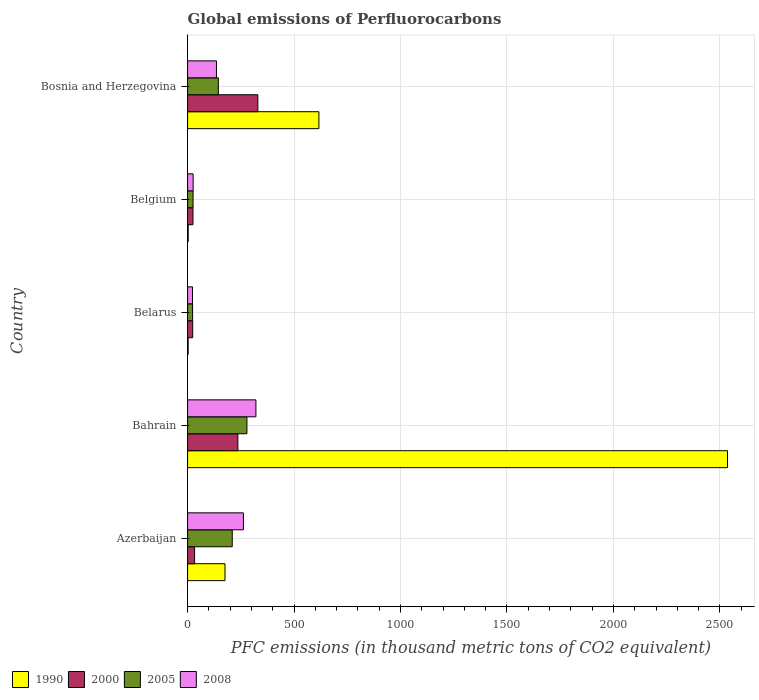How many different coloured bars are there?
Your answer should be compact. 4. Are the number of bars on each tick of the Y-axis equal?
Keep it short and to the point. Yes. How many bars are there on the 3rd tick from the bottom?
Offer a very short reply. 4. What is the label of the 5th group of bars from the top?
Provide a short and direct response. Azerbaijan. What is the global emissions of Perfluorocarbons in 2005 in Belgium?
Provide a succinct answer. 25.7. Across all countries, what is the maximum global emissions of Perfluorocarbons in 2008?
Offer a very short reply. 320.9. Across all countries, what is the minimum global emissions of Perfluorocarbons in 2005?
Your answer should be compact. 23.4. In which country was the global emissions of Perfluorocarbons in 2000 maximum?
Provide a short and direct response. Bosnia and Herzegovina. In which country was the global emissions of Perfluorocarbons in 1990 minimum?
Offer a terse response. Belarus. What is the total global emissions of Perfluorocarbons in 1990 in the graph?
Provide a short and direct response. 3333.5. What is the difference between the global emissions of Perfluorocarbons in 2005 in Azerbaijan and that in Belgium?
Your answer should be very brief. 184. What is the difference between the global emissions of Perfluorocarbons in 2005 in Belarus and the global emissions of Perfluorocarbons in 2000 in Belgium?
Provide a succinct answer. -1.8. What is the average global emissions of Perfluorocarbons in 2000 per country?
Your answer should be compact. 129.58. What is the difference between the global emissions of Perfluorocarbons in 1990 and global emissions of Perfluorocarbons in 2005 in Bosnia and Herzegovina?
Keep it short and to the point. 472.3. In how many countries, is the global emissions of Perfluorocarbons in 2000 greater than 1000 thousand metric tons?
Keep it short and to the point. 0. What is the ratio of the global emissions of Perfluorocarbons in 2005 in Azerbaijan to that in Belgium?
Offer a terse response. 8.16. Is the global emissions of Perfluorocarbons in 1990 in Azerbaijan less than that in Bahrain?
Provide a short and direct response. Yes. What is the difference between the highest and the second highest global emissions of Perfluorocarbons in 2000?
Offer a terse response. 93.8. What is the difference between the highest and the lowest global emissions of Perfluorocarbons in 2005?
Keep it short and to the point. 255.2. Is it the case that in every country, the sum of the global emissions of Perfluorocarbons in 2000 and global emissions of Perfluorocarbons in 2008 is greater than the sum of global emissions of Perfluorocarbons in 2005 and global emissions of Perfluorocarbons in 1990?
Your answer should be very brief. No. What does the 4th bar from the top in Bosnia and Herzegovina represents?
Your response must be concise. 1990. Is it the case that in every country, the sum of the global emissions of Perfluorocarbons in 2000 and global emissions of Perfluorocarbons in 2008 is greater than the global emissions of Perfluorocarbons in 1990?
Keep it short and to the point. No. How many bars are there?
Keep it short and to the point. 20. Does the graph contain grids?
Offer a very short reply. Yes. Where does the legend appear in the graph?
Ensure brevity in your answer.  Bottom left. How many legend labels are there?
Offer a terse response. 4. What is the title of the graph?
Offer a terse response. Global emissions of Perfluorocarbons. What is the label or title of the X-axis?
Provide a short and direct response. PFC emissions (in thousand metric tons of CO2 equivalent). What is the PFC emissions (in thousand metric tons of CO2 equivalent) of 1990 in Azerbaijan?
Your answer should be very brief. 175.6. What is the PFC emissions (in thousand metric tons of CO2 equivalent) in 2000 in Azerbaijan?
Provide a succinct answer. 32.8. What is the PFC emissions (in thousand metric tons of CO2 equivalent) in 2005 in Azerbaijan?
Make the answer very short. 209.7. What is the PFC emissions (in thousand metric tons of CO2 equivalent) of 2008 in Azerbaijan?
Your answer should be very brief. 262.2. What is the PFC emissions (in thousand metric tons of CO2 equivalent) of 1990 in Bahrain?
Make the answer very short. 2535.7. What is the PFC emissions (in thousand metric tons of CO2 equivalent) of 2000 in Bahrain?
Provide a short and direct response. 236.1. What is the PFC emissions (in thousand metric tons of CO2 equivalent) in 2005 in Bahrain?
Your answer should be compact. 278.6. What is the PFC emissions (in thousand metric tons of CO2 equivalent) in 2008 in Bahrain?
Your answer should be compact. 320.9. What is the PFC emissions (in thousand metric tons of CO2 equivalent) in 2000 in Belarus?
Provide a succinct answer. 23.9. What is the PFC emissions (in thousand metric tons of CO2 equivalent) in 2005 in Belarus?
Offer a terse response. 23.4. What is the PFC emissions (in thousand metric tons of CO2 equivalent) of 2008 in Belarus?
Your response must be concise. 23.1. What is the PFC emissions (in thousand metric tons of CO2 equivalent) in 2000 in Belgium?
Make the answer very short. 25.2. What is the PFC emissions (in thousand metric tons of CO2 equivalent) of 2005 in Belgium?
Provide a succinct answer. 25.7. What is the PFC emissions (in thousand metric tons of CO2 equivalent) of 2008 in Belgium?
Make the answer very short. 26. What is the PFC emissions (in thousand metric tons of CO2 equivalent) of 1990 in Bosnia and Herzegovina?
Your answer should be compact. 616.7. What is the PFC emissions (in thousand metric tons of CO2 equivalent) in 2000 in Bosnia and Herzegovina?
Offer a very short reply. 329.9. What is the PFC emissions (in thousand metric tons of CO2 equivalent) in 2005 in Bosnia and Herzegovina?
Ensure brevity in your answer.  144.4. What is the PFC emissions (in thousand metric tons of CO2 equivalent) of 2008 in Bosnia and Herzegovina?
Your response must be concise. 135.6. Across all countries, what is the maximum PFC emissions (in thousand metric tons of CO2 equivalent) in 1990?
Give a very brief answer. 2535.7. Across all countries, what is the maximum PFC emissions (in thousand metric tons of CO2 equivalent) of 2000?
Offer a very short reply. 329.9. Across all countries, what is the maximum PFC emissions (in thousand metric tons of CO2 equivalent) in 2005?
Provide a short and direct response. 278.6. Across all countries, what is the maximum PFC emissions (in thousand metric tons of CO2 equivalent) of 2008?
Make the answer very short. 320.9. Across all countries, what is the minimum PFC emissions (in thousand metric tons of CO2 equivalent) of 1990?
Make the answer very short. 2.6. Across all countries, what is the minimum PFC emissions (in thousand metric tons of CO2 equivalent) in 2000?
Your answer should be very brief. 23.9. Across all countries, what is the minimum PFC emissions (in thousand metric tons of CO2 equivalent) in 2005?
Give a very brief answer. 23.4. Across all countries, what is the minimum PFC emissions (in thousand metric tons of CO2 equivalent) of 2008?
Provide a short and direct response. 23.1. What is the total PFC emissions (in thousand metric tons of CO2 equivalent) of 1990 in the graph?
Your answer should be very brief. 3333.5. What is the total PFC emissions (in thousand metric tons of CO2 equivalent) in 2000 in the graph?
Ensure brevity in your answer.  647.9. What is the total PFC emissions (in thousand metric tons of CO2 equivalent) in 2005 in the graph?
Keep it short and to the point. 681.8. What is the total PFC emissions (in thousand metric tons of CO2 equivalent) in 2008 in the graph?
Your answer should be compact. 767.8. What is the difference between the PFC emissions (in thousand metric tons of CO2 equivalent) in 1990 in Azerbaijan and that in Bahrain?
Offer a terse response. -2360.1. What is the difference between the PFC emissions (in thousand metric tons of CO2 equivalent) of 2000 in Azerbaijan and that in Bahrain?
Keep it short and to the point. -203.3. What is the difference between the PFC emissions (in thousand metric tons of CO2 equivalent) of 2005 in Azerbaijan and that in Bahrain?
Offer a very short reply. -68.9. What is the difference between the PFC emissions (in thousand metric tons of CO2 equivalent) in 2008 in Azerbaijan and that in Bahrain?
Your answer should be compact. -58.7. What is the difference between the PFC emissions (in thousand metric tons of CO2 equivalent) of 1990 in Azerbaijan and that in Belarus?
Offer a very short reply. 173. What is the difference between the PFC emissions (in thousand metric tons of CO2 equivalent) of 2000 in Azerbaijan and that in Belarus?
Provide a succinct answer. 8.9. What is the difference between the PFC emissions (in thousand metric tons of CO2 equivalent) in 2005 in Azerbaijan and that in Belarus?
Provide a short and direct response. 186.3. What is the difference between the PFC emissions (in thousand metric tons of CO2 equivalent) of 2008 in Azerbaijan and that in Belarus?
Keep it short and to the point. 239.1. What is the difference between the PFC emissions (in thousand metric tons of CO2 equivalent) of 1990 in Azerbaijan and that in Belgium?
Your response must be concise. 172.7. What is the difference between the PFC emissions (in thousand metric tons of CO2 equivalent) of 2005 in Azerbaijan and that in Belgium?
Make the answer very short. 184. What is the difference between the PFC emissions (in thousand metric tons of CO2 equivalent) of 2008 in Azerbaijan and that in Belgium?
Your response must be concise. 236.2. What is the difference between the PFC emissions (in thousand metric tons of CO2 equivalent) in 1990 in Azerbaijan and that in Bosnia and Herzegovina?
Keep it short and to the point. -441.1. What is the difference between the PFC emissions (in thousand metric tons of CO2 equivalent) in 2000 in Azerbaijan and that in Bosnia and Herzegovina?
Provide a succinct answer. -297.1. What is the difference between the PFC emissions (in thousand metric tons of CO2 equivalent) of 2005 in Azerbaijan and that in Bosnia and Herzegovina?
Offer a very short reply. 65.3. What is the difference between the PFC emissions (in thousand metric tons of CO2 equivalent) of 2008 in Azerbaijan and that in Bosnia and Herzegovina?
Your answer should be compact. 126.6. What is the difference between the PFC emissions (in thousand metric tons of CO2 equivalent) in 1990 in Bahrain and that in Belarus?
Offer a terse response. 2533.1. What is the difference between the PFC emissions (in thousand metric tons of CO2 equivalent) of 2000 in Bahrain and that in Belarus?
Give a very brief answer. 212.2. What is the difference between the PFC emissions (in thousand metric tons of CO2 equivalent) of 2005 in Bahrain and that in Belarus?
Offer a terse response. 255.2. What is the difference between the PFC emissions (in thousand metric tons of CO2 equivalent) of 2008 in Bahrain and that in Belarus?
Your answer should be compact. 297.8. What is the difference between the PFC emissions (in thousand metric tons of CO2 equivalent) in 1990 in Bahrain and that in Belgium?
Offer a terse response. 2532.8. What is the difference between the PFC emissions (in thousand metric tons of CO2 equivalent) in 2000 in Bahrain and that in Belgium?
Offer a very short reply. 210.9. What is the difference between the PFC emissions (in thousand metric tons of CO2 equivalent) in 2005 in Bahrain and that in Belgium?
Provide a succinct answer. 252.9. What is the difference between the PFC emissions (in thousand metric tons of CO2 equivalent) in 2008 in Bahrain and that in Belgium?
Ensure brevity in your answer.  294.9. What is the difference between the PFC emissions (in thousand metric tons of CO2 equivalent) in 1990 in Bahrain and that in Bosnia and Herzegovina?
Provide a succinct answer. 1919. What is the difference between the PFC emissions (in thousand metric tons of CO2 equivalent) of 2000 in Bahrain and that in Bosnia and Herzegovina?
Give a very brief answer. -93.8. What is the difference between the PFC emissions (in thousand metric tons of CO2 equivalent) in 2005 in Bahrain and that in Bosnia and Herzegovina?
Your response must be concise. 134.2. What is the difference between the PFC emissions (in thousand metric tons of CO2 equivalent) of 2008 in Bahrain and that in Bosnia and Herzegovina?
Your response must be concise. 185.3. What is the difference between the PFC emissions (in thousand metric tons of CO2 equivalent) in 1990 in Belarus and that in Belgium?
Ensure brevity in your answer.  -0.3. What is the difference between the PFC emissions (in thousand metric tons of CO2 equivalent) in 2000 in Belarus and that in Belgium?
Your answer should be very brief. -1.3. What is the difference between the PFC emissions (in thousand metric tons of CO2 equivalent) in 1990 in Belarus and that in Bosnia and Herzegovina?
Your response must be concise. -614.1. What is the difference between the PFC emissions (in thousand metric tons of CO2 equivalent) in 2000 in Belarus and that in Bosnia and Herzegovina?
Your answer should be very brief. -306. What is the difference between the PFC emissions (in thousand metric tons of CO2 equivalent) of 2005 in Belarus and that in Bosnia and Herzegovina?
Make the answer very short. -121. What is the difference between the PFC emissions (in thousand metric tons of CO2 equivalent) of 2008 in Belarus and that in Bosnia and Herzegovina?
Provide a succinct answer. -112.5. What is the difference between the PFC emissions (in thousand metric tons of CO2 equivalent) of 1990 in Belgium and that in Bosnia and Herzegovina?
Your answer should be very brief. -613.8. What is the difference between the PFC emissions (in thousand metric tons of CO2 equivalent) of 2000 in Belgium and that in Bosnia and Herzegovina?
Give a very brief answer. -304.7. What is the difference between the PFC emissions (in thousand metric tons of CO2 equivalent) of 2005 in Belgium and that in Bosnia and Herzegovina?
Your answer should be very brief. -118.7. What is the difference between the PFC emissions (in thousand metric tons of CO2 equivalent) in 2008 in Belgium and that in Bosnia and Herzegovina?
Make the answer very short. -109.6. What is the difference between the PFC emissions (in thousand metric tons of CO2 equivalent) of 1990 in Azerbaijan and the PFC emissions (in thousand metric tons of CO2 equivalent) of 2000 in Bahrain?
Offer a terse response. -60.5. What is the difference between the PFC emissions (in thousand metric tons of CO2 equivalent) of 1990 in Azerbaijan and the PFC emissions (in thousand metric tons of CO2 equivalent) of 2005 in Bahrain?
Your answer should be compact. -103. What is the difference between the PFC emissions (in thousand metric tons of CO2 equivalent) in 1990 in Azerbaijan and the PFC emissions (in thousand metric tons of CO2 equivalent) in 2008 in Bahrain?
Provide a short and direct response. -145.3. What is the difference between the PFC emissions (in thousand metric tons of CO2 equivalent) in 2000 in Azerbaijan and the PFC emissions (in thousand metric tons of CO2 equivalent) in 2005 in Bahrain?
Your answer should be very brief. -245.8. What is the difference between the PFC emissions (in thousand metric tons of CO2 equivalent) in 2000 in Azerbaijan and the PFC emissions (in thousand metric tons of CO2 equivalent) in 2008 in Bahrain?
Offer a very short reply. -288.1. What is the difference between the PFC emissions (in thousand metric tons of CO2 equivalent) of 2005 in Azerbaijan and the PFC emissions (in thousand metric tons of CO2 equivalent) of 2008 in Bahrain?
Your answer should be compact. -111.2. What is the difference between the PFC emissions (in thousand metric tons of CO2 equivalent) in 1990 in Azerbaijan and the PFC emissions (in thousand metric tons of CO2 equivalent) in 2000 in Belarus?
Provide a succinct answer. 151.7. What is the difference between the PFC emissions (in thousand metric tons of CO2 equivalent) of 1990 in Azerbaijan and the PFC emissions (in thousand metric tons of CO2 equivalent) of 2005 in Belarus?
Give a very brief answer. 152.2. What is the difference between the PFC emissions (in thousand metric tons of CO2 equivalent) of 1990 in Azerbaijan and the PFC emissions (in thousand metric tons of CO2 equivalent) of 2008 in Belarus?
Your answer should be very brief. 152.5. What is the difference between the PFC emissions (in thousand metric tons of CO2 equivalent) of 2000 in Azerbaijan and the PFC emissions (in thousand metric tons of CO2 equivalent) of 2005 in Belarus?
Make the answer very short. 9.4. What is the difference between the PFC emissions (in thousand metric tons of CO2 equivalent) in 2005 in Azerbaijan and the PFC emissions (in thousand metric tons of CO2 equivalent) in 2008 in Belarus?
Your response must be concise. 186.6. What is the difference between the PFC emissions (in thousand metric tons of CO2 equivalent) in 1990 in Azerbaijan and the PFC emissions (in thousand metric tons of CO2 equivalent) in 2000 in Belgium?
Give a very brief answer. 150.4. What is the difference between the PFC emissions (in thousand metric tons of CO2 equivalent) in 1990 in Azerbaijan and the PFC emissions (in thousand metric tons of CO2 equivalent) in 2005 in Belgium?
Provide a short and direct response. 149.9. What is the difference between the PFC emissions (in thousand metric tons of CO2 equivalent) of 1990 in Azerbaijan and the PFC emissions (in thousand metric tons of CO2 equivalent) of 2008 in Belgium?
Ensure brevity in your answer.  149.6. What is the difference between the PFC emissions (in thousand metric tons of CO2 equivalent) of 2000 in Azerbaijan and the PFC emissions (in thousand metric tons of CO2 equivalent) of 2005 in Belgium?
Make the answer very short. 7.1. What is the difference between the PFC emissions (in thousand metric tons of CO2 equivalent) of 2005 in Azerbaijan and the PFC emissions (in thousand metric tons of CO2 equivalent) of 2008 in Belgium?
Ensure brevity in your answer.  183.7. What is the difference between the PFC emissions (in thousand metric tons of CO2 equivalent) in 1990 in Azerbaijan and the PFC emissions (in thousand metric tons of CO2 equivalent) in 2000 in Bosnia and Herzegovina?
Offer a terse response. -154.3. What is the difference between the PFC emissions (in thousand metric tons of CO2 equivalent) in 1990 in Azerbaijan and the PFC emissions (in thousand metric tons of CO2 equivalent) in 2005 in Bosnia and Herzegovina?
Make the answer very short. 31.2. What is the difference between the PFC emissions (in thousand metric tons of CO2 equivalent) in 2000 in Azerbaijan and the PFC emissions (in thousand metric tons of CO2 equivalent) in 2005 in Bosnia and Herzegovina?
Keep it short and to the point. -111.6. What is the difference between the PFC emissions (in thousand metric tons of CO2 equivalent) in 2000 in Azerbaijan and the PFC emissions (in thousand metric tons of CO2 equivalent) in 2008 in Bosnia and Herzegovina?
Make the answer very short. -102.8. What is the difference between the PFC emissions (in thousand metric tons of CO2 equivalent) in 2005 in Azerbaijan and the PFC emissions (in thousand metric tons of CO2 equivalent) in 2008 in Bosnia and Herzegovina?
Your answer should be compact. 74.1. What is the difference between the PFC emissions (in thousand metric tons of CO2 equivalent) of 1990 in Bahrain and the PFC emissions (in thousand metric tons of CO2 equivalent) of 2000 in Belarus?
Give a very brief answer. 2511.8. What is the difference between the PFC emissions (in thousand metric tons of CO2 equivalent) in 1990 in Bahrain and the PFC emissions (in thousand metric tons of CO2 equivalent) in 2005 in Belarus?
Keep it short and to the point. 2512.3. What is the difference between the PFC emissions (in thousand metric tons of CO2 equivalent) of 1990 in Bahrain and the PFC emissions (in thousand metric tons of CO2 equivalent) of 2008 in Belarus?
Your response must be concise. 2512.6. What is the difference between the PFC emissions (in thousand metric tons of CO2 equivalent) in 2000 in Bahrain and the PFC emissions (in thousand metric tons of CO2 equivalent) in 2005 in Belarus?
Give a very brief answer. 212.7. What is the difference between the PFC emissions (in thousand metric tons of CO2 equivalent) of 2000 in Bahrain and the PFC emissions (in thousand metric tons of CO2 equivalent) of 2008 in Belarus?
Your answer should be very brief. 213. What is the difference between the PFC emissions (in thousand metric tons of CO2 equivalent) in 2005 in Bahrain and the PFC emissions (in thousand metric tons of CO2 equivalent) in 2008 in Belarus?
Keep it short and to the point. 255.5. What is the difference between the PFC emissions (in thousand metric tons of CO2 equivalent) in 1990 in Bahrain and the PFC emissions (in thousand metric tons of CO2 equivalent) in 2000 in Belgium?
Provide a short and direct response. 2510.5. What is the difference between the PFC emissions (in thousand metric tons of CO2 equivalent) of 1990 in Bahrain and the PFC emissions (in thousand metric tons of CO2 equivalent) of 2005 in Belgium?
Give a very brief answer. 2510. What is the difference between the PFC emissions (in thousand metric tons of CO2 equivalent) in 1990 in Bahrain and the PFC emissions (in thousand metric tons of CO2 equivalent) in 2008 in Belgium?
Offer a very short reply. 2509.7. What is the difference between the PFC emissions (in thousand metric tons of CO2 equivalent) in 2000 in Bahrain and the PFC emissions (in thousand metric tons of CO2 equivalent) in 2005 in Belgium?
Your answer should be very brief. 210.4. What is the difference between the PFC emissions (in thousand metric tons of CO2 equivalent) of 2000 in Bahrain and the PFC emissions (in thousand metric tons of CO2 equivalent) of 2008 in Belgium?
Offer a terse response. 210.1. What is the difference between the PFC emissions (in thousand metric tons of CO2 equivalent) of 2005 in Bahrain and the PFC emissions (in thousand metric tons of CO2 equivalent) of 2008 in Belgium?
Your answer should be compact. 252.6. What is the difference between the PFC emissions (in thousand metric tons of CO2 equivalent) in 1990 in Bahrain and the PFC emissions (in thousand metric tons of CO2 equivalent) in 2000 in Bosnia and Herzegovina?
Offer a very short reply. 2205.8. What is the difference between the PFC emissions (in thousand metric tons of CO2 equivalent) of 1990 in Bahrain and the PFC emissions (in thousand metric tons of CO2 equivalent) of 2005 in Bosnia and Herzegovina?
Keep it short and to the point. 2391.3. What is the difference between the PFC emissions (in thousand metric tons of CO2 equivalent) in 1990 in Bahrain and the PFC emissions (in thousand metric tons of CO2 equivalent) in 2008 in Bosnia and Herzegovina?
Your response must be concise. 2400.1. What is the difference between the PFC emissions (in thousand metric tons of CO2 equivalent) of 2000 in Bahrain and the PFC emissions (in thousand metric tons of CO2 equivalent) of 2005 in Bosnia and Herzegovina?
Provide a short and direct response. 91.7. What is the difference between the PFC emissions (in thousand metric tons of CO2 equivalent) in 2000 in Bahrain and the PFC emissions (in thousand metric tons of CO2 equivalent) in 2008 in Bosnia and Herzegovina?
Give a very brief answer. 100.5. What is the difference between the PFC emissions (in thousand metric tons of CO2 equivalent) in 2005 in Bahrain and the PFC emissions (in thousand metric tons of CO2 equivalent) in 2008 in Bosnia and Herzegovina?
Provide a succinct answer. 143. What is the difference between the PFC emissions (in thousand metric tons of CO2 equivalent) in 1990 in Belarus and the PFC emissions (in thousand metric tons of CO2 equivalent) in 2000 in Belgium?
Ensure brevity in your answer.  -22.6. What is the difference between the PFC emissions (in thousand metric tons of CO2 equivalent) in 1990 in Belarus and the PFC emissions (in thousand metric tons of CO2 equivalent) in 2005 in Belgium?
Offer a very short reply. -23.1. What is the difference between the PFC emissions (in thousand metric tons of CO2 equivalent) of 1990 in Belarus and the PFC emissions (in thousand metric tons of CO2 equivalent) of 2008 in Belgium?
Offer a very short reply. -23.4. What is the difference between the PFC emissions (in thousand metric tons of CO2 equivalent) of 2005 in Belarus and the PFC emissions (in thousand metric tons of CO2 equivalent) of 2008 in Belgium?
Give a very brief answer. -2.6. What is the difference between the PFC emissions (in thousand metric tons of CO2 equivalent) in 1990 in Belarus and the PFC emissions (in thousand metric tons of CO2 equivalent) in 2000 in Bosnia and Herzegovina?
Provide a short and direct response. -327.3. What is the difference between the PFC emissions (in thousand metric tons of CO2 equivalent) of 1990 in Belarus and the PFC emissions (in thousand metric tons of CO2 equivalent) of 2005 in Bosnia and Herzegovina?
Provide a succinct answer. -141.8. What is the difference between the PFC emissions (in thousand metric tons of CO2 equivalent) in 1990 in Belarus and the PFC emissions (in thousand metric tons of CO2 equivalent) in 2008 in Bosnia and Herzegovina?
Offer a terse response. -133. What is the difference between the PFC emissions (in thousand metric tons of CO2 equivalent) of 2000 in Belarus and the PFC emissions (in thousand metric tons of CO2 equivalent) of 2005 in Bosnia and Herzegovina?
Make the answer very short. -120.5. What is the difference between the PFC emissions (in thousand metric tons of CO2 equivalent) of 2000 in Belarus and the PFC emissions (in thousand metric tons of CO2 equivalent) of 2008 in Bosnia and Herzegovina?
Ensure brevity in your answer.  -111.7. What is the difference between the PFC emissions (in thousand metric tons of CO2 equivalent) in 2005 in Belarus and the PFC emissions (in thousand metric tons of CO2 equivalent) in 2008 in Bosnia and Herzegovina?
Offer a terse response. -112.2. What is the difference between the PFC emissions (in thousand metric tons of CO2 equivalent) of 1990 in Belgium and the PFC emissions (in thousand metric tons of CO2 equivalent) of 2000 in Bosnia and Herzegovina?
Provide a short and direct response. -327. What is the difference between the PFC emissions (in thousand metric tons of CO2 equivalent) in 1990 in Belgium and the PFC emissions (in thousand metric tons of CO2 equivalent) in 2005 in Bosnia and Herzegovina?
Give a very brief answer. -141.5. What is the difference between the PFC emissions (in thousand metric tons of CO2 equivalent) of 1990 in Belgium and the PFC emissions (in thousand metric tons of CO2 equivalent) of 2008 in Bosnia and Herzegovina?
Your answer should be compact. -132.7. What is the difference between the PFC emissions (in thousand metric tons of CO2 equivalent) in 2000 in Belgium and the PFC emissions (in thousand metric tons of CO2 equivalent) in 2005 in Bosnia and Herzegovina?
Make the answer very short. -119.2. What is the difference between the PFC emissions (in thousand metric tons of CO2 equivalent) of 2000 in Belgium and the PFC emissions (in thousand metric tons of CO2 equivalent) of 2008 in Bosnia and Herzegovina?
Your answer should be compact. -110.4. What is the difference between the PFC emissions (in thousand metric tons of CO2 equivalent) in 2005 in Belgium and the PFC emissions (in thousand metric tons of CO2 equivalent) in 2008 in Bosnia and Herzegovina?
Keep it short and to the point. -109.9. What is the average PFC emissions (in thousand metric tons of CO2 equivalent) of 1990 per country?
Your answer should be compact. 666.7. What is the average PFC emissions (in thousand metric tons of CO2 equivalent) in 2000 per country?
Provide a short and direct response. 129.58. What is the average PFC emissions (in thousand metric tons of CO2 equivalent) in 2005 per country?
Offer a terse response. 136.36. What is the average PFC emissions (in thousand metric tons of CO2 equivalent) in 2008 per country?
Provide a short and direct response. 153.56. What is the difference between the PFC emissions (in thousand metric tons of CO2 equivalent) in 1990 and PFC emissions (in thousand metric tons of CO2 equivalent) in 2000 in Azerbaijan?
Provide a succinct answer. 142.8. What is the difference between the PFC emissions (in thousand metric tons of CO2 equivalent) in 1990 and PFC emissions (in thousand metric tons of CO2 equivalent) in 2005 in Azerbaijan?
Make the answer very short. -34.1. What is the difference between the PFC emissions (in thousand metric tons of CO2 equivalent) in 1990 and PFC emissions (in thousand metric tons of CO2 equivalent) in 2008 in Azerbaijan?
Keep it short and to the point. -86.6. What is the difference between the PFC emissions (in thousand metric tons of CO2 equivalent) of 2000 and PFC emissions (in thousand metric tons of CO2 equivalent) of 2005 in Azerbaijan?
Make the answer very short. -176.9. What is the difference between the PFC emissions (in thousand metric tons of CO2 equivalent) of 2000 and PFC emissions (in thousand metric tons of CO2 equivalent) of 2008 in Azerbaijan?
Offer a terse response. -229.4. What is the difference between the PFC emissions (in thousand metric tons of CO2 equivalent) in 2005 and PFC emissions (in thousand metric tons of CO2 equivalent) in 2008 in Azerbaijan?
Your answer should be compact. -52.5. What is the difference between the PFC emissions (in thousand metric tons of CO2 equivalent) of 1990 and PFC emissions (in thousand metric tons of CO2 equivalent) of 2000 in Bahrain?
Offer a terse response. 2299.6. What is the difference between the PFC emissions (in thousand metric tons of CO2 equivalent) of 1990 and PFC emissions (in thousand metric tons of CO2 equivalent) of 2005 in Bahrain?
Provide a succinct answer. 2257.1. What is the difference between the PFC emissions (in thousand metric tons of CO2 equivalent) in 1990 and PFC emissions (in thousand metric tons of CO2 equivalent) in 2008 in Bahrain?
Give a very brief answer. 2214.8. What is the difference between the PFC emissions (in thousand metric tons of CO2 equivalent) of 2000 and PFC emissions (in thousand metric tons of CO2 equivalent) of 2005 in Bahrain?
Your answer should be compact. -42.5. What is the difference between the PFC emissions (in thousand metric tons of CO2 equivalent) of 2000 and PFC emissions (in thousand metric tons of CO2 equivalent) of 2008 in Bahrain?
Offer a terse response. -84.8. What is the difference between the PFC emissions (in thousand metric tons of CO2 equivalent) in 2005 and PFC emissions (in thousand metric tons of CO2 equivalent) in 2008 in Bahrain?
Ensure brevity in your answer.  -42.3. What is the difference between the PFC emissions (in thousand metric tons of CO2 equivalent) of 1990 and PFC emissions (in thousand metric tons of CO2 equivalent) of 2000 in Belarus?
Provide a succinct answer. -21.3. What is the difference between the PFC emissions (in thousand metric tons of CO2 equivalent) in 1990 and PFC emissions (in thousand metric tons of CO2 equivalent) in 2005 in Belarus?
Give a very brief answer. -20.8. What is the difference between the PFC emissions (in thousand metric tons of CO2 equivalent) of 1990 and PFC emissions (in thousand metric tons of CO2 equivalent) of 2008 in Belarus?
Make the answer very short. -20.5. What is the difference between the PFC emissions (in thousand metric tons of CO2 equivalent) of 2000 and PFC emissions (in thousand metric tons of CO2 equivalent) of 2005 in Belarus?
Ensure brevity in your answer.  0.5. What is the difference between the PFC emissions (in thousand metric tons of CO2 equivalent) of 2005 and PFC emissions (in thousand metric tons of CO2 equivalent) of 2008 in Belarus?
Provide a succinct answer. 0.3. What is the difference between the PFC emissions (in thousand metric tons of CO2 equivalent) in 1990 and PFC emissions (in thousand metric tons of CO2 equivalent) in 2000 in Belgium?
Offer a terse response. -22.3. What is the difference between the PFC emissions (in thousand metric tons of CO2 equivalent) in 1990 and PFC emissions (in thousand metric tons of CO2 equivalent) in 2005 in Belgium?
Your answer should be very brief. -22.8. What is the difference between the PFC emissions (in thousand metric tons of CO2 equivalent) of 1990 and PFC emissions (in thousand metric tons of CO2 equivalent) of 2008 in Belgium?
Your answer should be compact. -23.1. What is the difference between the PFC emissions (in thousand metric tons of CO2 equivalent) of 2000 and PFC emissions (in thousand metric tons of CO2 equivalent) of 2005 in Belgium?
Make the answer very short. -0.5. What is the difference between the PFC emissions (in thousand metric tons of CO2 equivalent) in 2000 and PFC emissions (in thousand metric tons of CO2 equivalent) in 2008 in Belgium?
Offer a terse response. -0.8. What is the difference between the PFC emissions (in thousand metric tons of CO2 equivalent) in 1990 and PFC emissions (in thousand metric tons of CO2 equivalent) in 2000 in Bosnia and Herzegovina?
Your response must be concise. 286.8. What is the difference between the PFC emissions (in thousand metric tons of CO2 equivalent) in 1990 and PFC emissions (in thousand metric tons of CO2 equivalent) in 2005 in Bosnia and Herzegovina?
Provide a short and direct response. 472.3. What is the difference between the PFC emissions (in thousand metric tons of CO2 equivalent) in 1990 and PFC emissions (in thousand metric tons of CO2 equivalent) in 2008 in Bosnia and Herzegovina?
Ensure brevity in your answer.  481.1. What is the difference between the PFC emissions (in thousand metric tons of CO2 equivalent) of 2000 and PFC emissions (in thousand metric tons of CO2 equivalent) of 2005 in Bosnia and Herzegovina?
Provide a short and direct response. 185.5. What is the difference between the PFC emissions (in thousand metric tons of CO2 equivalent) of 2000 and PFC emissions (in thousand metric tons of CO2 equivalent) of 2008 in Bosnia and Herzegovina?
Your answer should be compact. 194.3. What is the difference between the PFC emissions (in thousand metric tons of CO2 equivalent) in 2005 and PFC emissions (in thousand metric tons of CO2 equivalent) in 2008 in Bosnia and Herzegovina?
Ensure brevity in your answer.  8.8. What is the ratio of the PFC emissions (in thousand metric tons of CO2 equivalent) of 1990 in Azerbaijan to that in Bahrain?
Keep it short and to the point. 0.07. What is the ratio of the PFC emissions (in thousand metric tons of CO2 equivalent) in 2000 in Azerbaijan to that in Bahrain?
Ensure brevity in your answer.  0.14. What is the ratio of the PFC emissions (in thousand metric tons of CO2 equivalent) of 2005 in Azerbaijan to that in Bahrain?
Give a very brief answer. 0.75. What is the ratio of the PFC emissions (in thousand metric tons of CO2 equivalent) in 2008 in Azerbaijan to that in Bahrain?
Keep it short and to the point. 0.82. What is the ratio of the PFC emissions (in thousand metric tons of CO2 equivalent) of 1990 in Azerbaijan to that in Belarus?
Your response must be concise. 67.54. What is the ratio of the PFC emissions (in thousand metric tons of CO2 equivalent) in 2000 in Azerbaijan to that in Belarus?
Keep it short and to the point. 1.37. What is the ratio of the PFC emissions (in thousand metric tons of CO2 equivalent) of 2005 in Azerbaijan to that in Belarus?
Keep it short and to the point. 8.96. What is the ratio of the PFC emissions (in thousand metric tons of CO2 equivalent) in 2008 in Azerbaijan to that in Belarus?
Ensure brevity in your answer.  11.35. What is the ratio of the PFC emissions (in thousand metric tons of CO2 equivalent) of 1990 in Azerbaijan to that in Belgium?
Your answer should be compact. 60.55. What is the ratio of the PFC emissions (in thousand metric tons of CO2 equivalent) in 2000 in Azerbaijan to that in Belgium?
Offer a terse response. 1.3. What is the ratio of the PFC emissions (in thousand metric tons of CO2 equivalent) of 2005 in Azerbaijan to that in Belgium?
Ensure brevity in your answer.  8.16. What is the ratio of the PFC emissions (in thousand metric tons of CO2 equivalent) in 2008 in Azerbaijan to that in Belgium?
Provide a short and direct response. 10.08. What is the ratio of the PFC emissions (in thousand metric tons of CO2 equivalent) in 1990 in Azerbaijan to that in Bosnia and Herzegovina?
Make the answer very short. 0.28. What is the ratio of the PFC emissions (in thousand metric tons of CO2 equivalent) in 2000 in Azerbaijan to that in Bosnia and Herzegovina?
Your answer should be very brief. 0.1. What is the ratio of the PFC emissions (in thousand metric tons of CO2 equivalent) in 2005 in Azerbaijan to that in Bosnia and Herzegovina?
Ensure brevity in your answer.  1.45. What is the ratio of the PFC emissions (in thousand metric tons of CO2 equivalent) in 2008 in Azerbaijan to that in Bosnia and Herzegovina?
Provide a short and direct response. 1.93. What is the ratio of the PFC emissions (in thousand metric tons of CO2 equivalent) in 1990 in Bahrain to that in Belarus?
Your answer should be very brief. 975.27. What is the ratio of the PFC emissions (in thousand metric tons of CO2 equivalent) in 2000 in Bahrain to that in Belarus?
Offer a terse response. 9.88. What is the ratio of the PFC emissions (in thousand metric tons of CO2 equivalent) in 2005 in Bahrain to that in Belarus?
Offer a terse response. 11.91. What is the ratio of the PFC emissions (in thousand metric tons of CO2 equivalent) in 2008 in Bahrain to that in Belarus?
Your answer should be compact. 13.89. What is the ratio of the PFC emissions (in thousand metric tons of CO2 equivalent) of 1990 in Bahrain to that in Belgium?
Keep it short and to the point. 874.38. What is the ratio of the PFC emissions (in thousand metric tons of CO2 equivalent) in 2000 in Bahrain to that in Belgium?
Give a very brief answer. 9.37. What is the ratio of the PFC emissions (in thousand metric tons of CO2 equivalent) in 2005 in Bahrain to that in Belgium?
Offer a terse response. 10.84. What is the ratio of the PFC emissions (in thousand metric tons of CO2 equivalent) in 2008 in Bahrain to that in Belgium?
Give a very brief answer. 12.34. What is the ratio of the PFC emissions (in thousand metric tons of CO2 equivalent) in 1990 in Bahrain to that in Bosnia and Herzegovina?
Provide a short and direct response. 4.11. What is the ratio of the PFC emissions (in thousand metric tons of CO2 equivalent) of 2000 in Bahrain to that in Bosnia and Herzegovina?
Give a very brief answer. 0.72. What is the ratio of the PFC emissions (in thousand metric tons of CO2 equivalent) in 2005 in Bahrain to that in Bosnia and Herzegovina?
Ensure brevity in your answer.  1.93. What is the ratio of the PFC emissions (in thousand metric tons of CO2 equivalent) in 2008 in Bahrain to that in Bosnia and Herzegovina?
Your response must be concise. 2.37. What is the ratio of the PFC emissions (in thousand metric tons of CO2 equivalent) of 1990 in Belarus to that in Belgium?
Offer a very short reply. 0.9. What is the ratio of the PFC emissions (in thousand metric tons of CO2 equivalent) of 2000 in Belarus to that in Belgium?
Provide a succinct answer. 0.95. What is the ratio of the PFC emissions (in thousand metric tons of CO2 equivalent) in 2005 in Belarus to that in Belgium?
Your response must be concise. 0.91. What is the ratio of the PFC emissions (in thousand metric tons of CO2 equivalent) in 2008 in Belarus to that in Belgium?
Keep it short and to the point. 0.89. What is the ratio of the PFC emissions (in thousand metric tons of CO2 equivalent) in 1990 in Belarus to that in Bosnia and Herzegovina?
Your answer should be very brief. 0. What is the ratio of the PFC emissions (in thousand metric tons of CO2 equivalent) of 2000 in Belarus to that in Bosnia and Herzegovina?
Your answer should be very brief. 0.07. What is the ratio of the PFC emissions (in thousand metric tons of CO2 equivalent) in 2005 in Belarus to that in Bosnia and Herzegovina?
Keep it short and to the point. 0.16. What is the ratio of the PFC emissions (in thousand metric tons of CO2 equivalent) in 2008 in Belarus to that in Bosnia and Herzegovina?
Keep it short and to the point. 0.17. What is the ratio of the PFC emissions (in thousand metric tons of CO2 equivalent) of 1990 in Belgium to that in Bosnia and Herzegovina?
Give a very brief answer. 0. What is the ratio of the PFC emissions (in thousand metric tons of CO2 equivalent) in 2000 in Belgium to that in Bosnia and Herzegovina?
Your answer should be very brief. 0.08. What is the ratio of the PFC emissions (in thousand metric tons of CO2 equivalent) of 2005 in Belgium to that in Bosnia and Herzegovina?
Your answer should be very brief. 0.18. What is the ratio of the PFC emissions (in thousand metric tons of CO2 equivalent) of 2008 in Belgium to that in Bosnia and Herzegovina?
Ensure brevity in your answer.  0.19. What is the difference between the highest and the second highest PFC emissions (in thousand metric tons of CO2 equivalent) of 1990?
Your response must be concise. 1919. What is the difference between the highest and the second highest PFC emissions (in thousand metric tons of CO2 equivalent) of 2000?
Offer a very short reply. 93.8. What is the difference between the highest and the second highest PFC emissions (in thousand metric tons of CO2 equivalent) in 2005?
Your answer should be very brief. 68.9. What is the difference between the highest and the second highest PFC emissions (in thousand metric tons of CO2 equivalent) of 2008?
Keep it short and to the point. 58.7. What is the difference between the highest and the lowest PFC emissions (in thousand metric tons of CO2 equivalent) in 1990?
Give a very brief answer. 2533.1. What is the difference between the highest and the lowest PFC emissions (in thousand metric tons of CO2 equivalent) in 2000?
Make the answer very short. 306. What is the difference between the highest and the lowest PFC emissions (in thousand metric tons of CO2 equivalent) of 2005?
Offer a terse response. 255.2. What is the difference between the highest and the lowest PFC emissions (in thousand metric tons of CO2 equivalent) in 2008?
Your response must be concise. 297.8. 